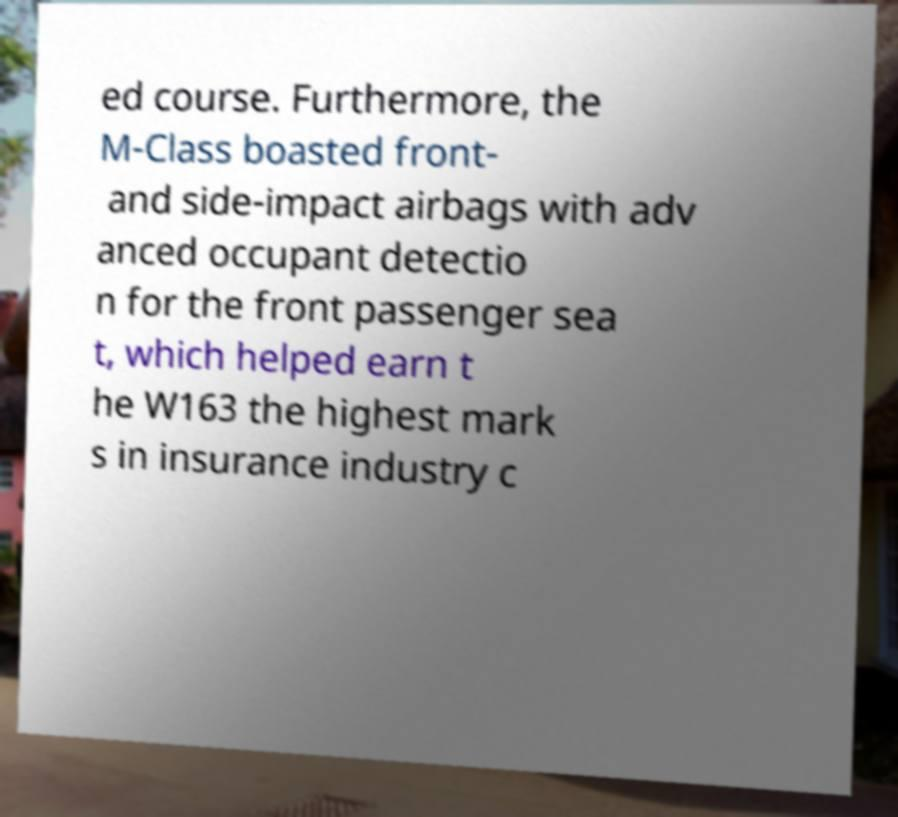Can you accurately transcribe the text from the provided image for me? ed course. Furthermore, the M-Class boasted front- and side-impact airbags with adv anced occupant detectio n for the front passenger sea t, which helped earn t he W163 the highest mark s in insurance industry c 